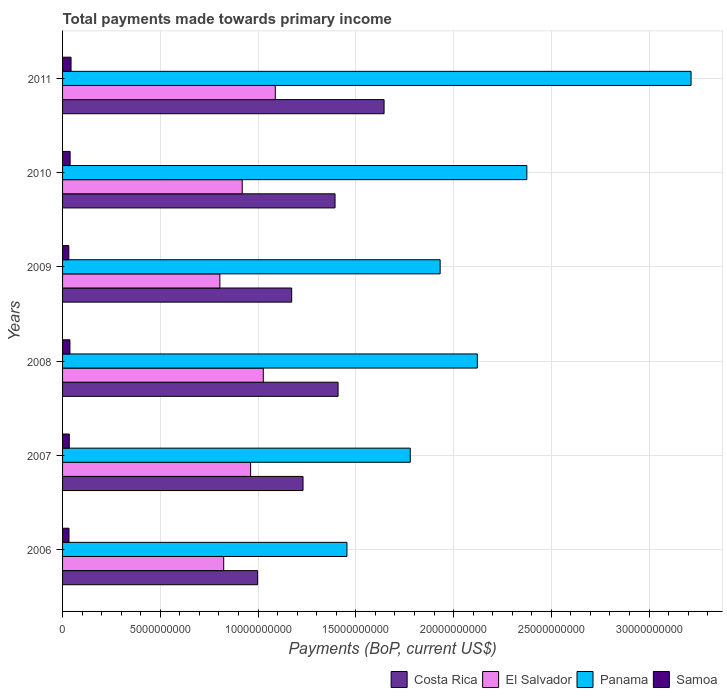How many different coloured bars are there?
Your response must be concise. 4. Are the number of bars per tick equal to the number of legend labels?
Give a very brief answer. Yes. Are the number of bars on each tick of the Y-axis equal?
Offer a terse response. Yes. How many bars are there on the 1st tick from the top?
Give a very brief answer. 4. In how many cases, is the number of bars for a given year not equal to the number of legend labels?
Offer a very short reply. 0. What is the total payments made towards primary income in Samoa in 2009?
Your answer should be very brief. 3.20e+08. Across all years, what is the maximum total payments made towards primary income in El Salvador?
Provide a short and direct response. 1.09e+1. Across all years, what is the minimum total payments made towards primary income in Samoa?
Your response must be concise. 3.20e+08. In which year was the total payments made towards primary income in Costa Rica minimum?
Your answer should be very brief. 2006. What is the total total payments made towards primary income in Samoa in the graph?
Your answer should be very brief. 2.19e+09. What is the difference between the total payments made towards primary income in Costa Rica in 2006 and that in 2007?
Offer a terse response. -2.32e+09. What is the difference between the total payments made towards primary income in Panama in 2010 and the total payments made towards primary income in El Salvador in 2009?
Provide a succinct answer. 1.57e+1. What is the average total payments made towards primary income in Costa Rica per year?
Your answer should be very brief. 1.31e+1. In the year 2011, what is the difference between the total payments made towards primary income in El Salvador and total payments made towards primary income in Samoa?
Provide a short and direct response. 1.04e+1. What is the ratio of the total payments made towards primary income in El Salvador in 2007 to that in 2011?
Your response must be concise. 0.88. Is the total payments made towards primary income in El Salvador in 2006 less than that in 2010?
Keep it short and to the point. Yes. Is the difference between the total payments made towards primary income in El Salvador in 2006 and 2011 greater than the difference between the total payments made towards primary income in Samoa in 2006 and 2011?
Make the answer very short. No. What is the difference between the highest and the second highest total payments made towards primary income in Samoa?
Offer a terse response. 4.78e+07. What is the difference between the highest and the lowest total payments made towards primary income in Panama?
Your response must be concise. 1.76e+1. In how many years, is the total payments made towards primary income in El Salvador greater than the average total payments made towards primary income in El Salvador taken over all years?
Offer a very short reply. 3. Is the sum of the total payments made towards primary income in Samoa in 2006 and 2011 greater than the maximum total payments made towards primary income in Panama across all years?
Your answer should be very brief. No. What does the 2nd bar from the top in 2011 represents?
Your response must be concise. Panama. What does the 4th bar from the bottom in 2009 represents?
Keep it short and to the point. Samoa. Is it the case that in every year, the sum of the total payments made towards primary income in Panama and total payments made towards primary income in Costa Rica is greater than the total payments made towards primary income in El Salvador?
Offer a terse response. Yes. How many years are there in the graph?
Make the answer very short. 6. Are the values on the major ticks of X-axis written in scientific E-notation?
Provide a succinct answer. No. Does the graph contain any zero values?
Ensure brevity in your answer.  No. Where does the legend appear in the graph?
Your response must be concise. Bottom right. How are the legend labels stacked?
Provide a succinct answer. Horizontal. What is the title of the graph?
Offer a terse response. Total payments made towards primary income. What is the label or title of the X-axis?
Offer a terse response. Payments (BoP, current US$). What is the Payments (BoP, current US$) in Costa Rica in 2006?
Ensure brevity in your answer.  9.98e+09. What is the Payments (BoP, current US$) in El Salvador in 2006?
Offer a very short reply. 8.24e+09. What is the Payments (BoP, current US$) of Panama in 2006?
Your answer should be compact. 1.45e+1. What is the Payments (BoP, current US$) in Samoa in 2006?
Offer a very short reply. 3.29e+08. What is the Payments (BoP, current US$) in Costa Rica in 2007?
Offer a very short reply. 1.23e+1. What is the Payments (BoP, current US$) of El Salvador in 2007?
Provide a short and direct response. 9.62e+09. What is the Payments (BoP, current US$) in Panama in 2007?
Provide a short and direct response. 1.78e+1. What is the Payments (BoP, current US$) of Samoa in 2007?
Your response must be concise. 3.44e+08. What is the Payments (BoP, current US$) of Costa Rica in 2008?
Provide a short and direct response. 1.41e+1. What is the Payments (BoP, current US$) of El Salvador in 2008?
Ensure brevity in your answer.  1.03e+1. What is the Payments (BoP, current US$) in Panama in 2008?
Provide a succinct answer. 2.12e+1. What is the Payments (BoP, current US$) in Samoa in 2008?
Your response must be concise. 3.77e+08. What is the Payments (BoP, current US$) in Costa Rica in 2009?
Provide a succinct answer. 1.17e+1. What is the Payments (BoP, current US$) in El Salvador in 2009?
Offer a very short reply. 8.05e+09. What is the Payments (BoP, current US$) of Panama in 2009?
Make the answer very short. 1.93e+1. What is the Payments (BoP, current US$) of Samoa in 2009?
Your answer should be compact. 3.20e+08. What is the Payments (BoP, current US$) of Costa Rica in 2010?
Your answer should be compact. 1.39e+1. What is the Payments (BoP, current US$) in El Salvador in 2010?
Make the answer very short. 9.19e+09. What is the Payments (BoP, current US$) of Panama in 2010?
Your answer should be compact. 2.37e+1. What is the Payments (BoP, current US$) of Samoa in 2010?
Keep it short and to the point. 3.86e+08. What is the Payments (BoP, current US$) of Costa Rica in 2011?
Your answer should be compact. 1.64e+1. What is the Payments (BoP, current US$) of El Salvador in 2011?
Give a very brief answer. 1.09e+1. What is the Payments (BoP, current US$) in Panama in 2011?
Your answer should be compact. 3.21e+1. What is the Payments (BoP, current US$) of Samoa in 2011?
Make the answer very short. 4.34e+08. Across all years, what is the maximum Payments (BoP, current US$) in Costa Rica?
Ensure brevity in your answer.  1.64e+1. Across all years, what is the maximum Payments (BoP, current US$) of El Salvador?
Ensure brevity in your answer.  1.09e+1. Across all years, what is the maximum Payments (BoP, current US$) of Panama?
Offer a very short reply. 3.21e+1. Across all years, what is the maximum Payments (BoP, current US$) in Samoa?
Provide a succinct answer. 4.34e+08. Across all years, what is the minimum Payments (BoP, current US$) in Costa Rica?
Provide a short and direct response. 9.98e+09. Across all years, what is the minimum Payments (BoP, current US$) in El Salvador?
Your response must be concise. 8.05e+09. Across all years, what is the minimum Payments (BoP, current US$) of Panama?
Offer a very short reply. 1.45e+1. Across all years, what is the minimum Payments (BoP, current US$) of Samoa?
Your answer should be compact. 3.20e+08. What is the total Payments (BoP, current US$) of Costa Rica in the graph?
Your answer should be very brief. 7.85e+1. What is the total Payments (BoP, current US$) in El Salvador in the graph?
Your answer should be very brief. 5.62e+1. What is the total Payments (BoP, current US$) in Panama in the graph?
Provide a succinct answer. 1.29e+11. What is the total Payments (BoP, current US$) of Samoa in the graph?
Offer a terse response. 2.19e+09. What is the difference between the Payments (BoP, current US$) in Costa Rica in 2006 and that in 2007?
Offer a terse response. -2.32e+09. What is the difference between the Payments (BoP, current US$) of El Salvador in 2006 and that in 2007?
Give a very brief answer. -1.38e+09. What is the difference between the Payments (BoP, current US$) in Panama in 2006 and that in 2007?
Your response must be concise. -3.24e+09. What is the difference between the Payments (BoP, current US$) in Samoa in 2006 and that in 2007?
Give a very brief answer. -1.56e+07. What is the difference between the Payments (BoP, current US$) in Costa Rica in 2006 and that in 2008?
Give a very brief answer. -4.12e+09. What is the difference between the Payments (BoP, current US$) in El Salvador in 2006 and that in 2008?
Offer a very short reply. -2.03e+09. What is the difference between the Payments (BoP, current US$) in Panama in 2006 and that in 2008?
Your response must be concise. -6.67e+09. What is the difference between the Payments (BoP, current US$) of Samoa in 2006 and that in 2008?
Your answer should be very brief. -4.81e+07. What is the difference between the Payments (BoP, current US$) in Costa Rica in 2006 and that in 2009?
Your answer should be very brief. -1.74e+09. What is the difference between the Payments (BoP, current US$) of El Salvador in 2006 and that in 2009?
Offer a very short reply. 1.96e+08. What is the difference between the Payments (BoP, current US$) of Panama in 2006 and that in 2009?
Your answer should be compact. -4.77e+09. What is the difference between the Payments (BoP, current US$) of Samoa in 2006 and that in 2009?
Give a very brief answer. 8.97e+06. What is the difference between the Payments (BoP, current US$) in Costa Rica in 2006 and that in 2010?
Offer a terse response. -3.96e+09. What is the difference between the Payments (BoP, current US$) of El Salvador in 2006 and that in 2010?
Your answer should be very brief. -9.47e+08. What is the difference between the Payments (BoP, current US$) of Panama in 2006 and that in 2010?
Your answer should be very brief. -9.20e+09. What is the difference between the Payments (BoP, current US$) of Samoa in 2006 and that in 2010?
Your response must be concise. -5.76e+07. What is the difference between the Payments (BoP, current US$) of Costa Rica in 2006 and that in 2011?
Keep it short and to the point. -6.47e+09. What is the difference between the Payments (BoP, current US$) in El Salvador in 2006 and that in 2011?
Your response must be concise. -2.64e+09. What is the difference between the Payments (BoP, current US$) in Panama in 2006 and that in 2011?
Keep it short and to the point. -1.76e+1. What is the difference between the Payments (BoP, current US$) in Samoa in 2006 and that in 2011?
Your response must be concise. -1.05e+08. What is the difference between the Payments (BoP, current US$) of Costa Rica in 2007 and that in 2008?
Give a very brief answer. -1.79e+09. What is the difference between the Payments (BoP, current US$) in El Salvador in 2007 and that in 2008?
Offer a very short reply. -6.48e+08. What is the difference between the Payments (BoP, current US$) in Panama in 2007 and that in 2008?
Offer a very short reply. -3.43e+09. What is the difference between the Payments (BoP, current US$) of Samoa in 2007 and that in 2008?
Offer a terse response. -3.25e+07. What is the difference between the Payments (BoP, current US$) of Costa Rica in 2007 and that in 2009?
Give a very brief answer. 5.80e+08. What is the difference between the Payments (BoP, current US$) in El Salvador in 2007 and that in 2009?
Provide a short and direct response. 1.57e+09. What is the difference between the Payments (BoP, current US$) of Panama in 2007 and that in 2009?
Your answer should be very brief. -1.53e+09. What is the difference between the Payments (BoP, current US$) of Samoa in 2007 and that in 2009?
Your answer should be very brief. 2.46e+07. What is the difference between the Payments (BoP, current US$) in Costa Rica in 2007 and that in 2010?
Give a very brief answer. -1.64e+09. What is the difference between the Payments (BoP, current US$) of El Salvador in 2007 and that in 2010?
Make the answer very short. 4.30e+08. What is the difference between the Payments (BoP, current US$) of Panama in 2007 and that in 2010?
Offer a terse response. -5.96e+09. What is the difference between the Payments (BoP, current US$) in Samoa in 2007 and that in 2010?
Your answer should be very brief. -4.20e+07. What is the difference between the Payments (BoP, current US$) in Costa Rica in 2007 and that in 2011?
Keep it short and to the point. -4.15e+09. What is the difference between the Payments (BoP, current US$) of El Salvador in 2007 and that in 2011?
Provide a short and direct response. -1.26e+09. What is the difference between the Payments (BoP, current US$) in Panama in 2007 and that in 2011?
Provide a succinct answer. -1.44e+1. What is the difference between the Payments (BoP, current US$) of Samoa in 2007 and that in 2011?
Offer a terse response. -8.98e+07. What is the difference between the Payments (BoP, current US$) of Costa Rica in 2008 and that in 2009?
Offer a terse response. 2.37e+09. What is the difference between the Payments (BoP, current US$) of El Salvador in 2008 and that in 2009?
Your answer should be compact. 2.22e+09. What is the difference between the Payments (BoP, current US$) of Panama in 2008 and that in 2009?
Your answer should be compact. 1.90e+09. What is the difference between the Payments (BoP, current US$) of Samoa in 2008 and that in 2009?
Give a very brief answer. 5.70e+07. What is the difference between the Payments (BoP, current US$) of Costa Rica in 2008 and that in 2010?
Make the answer very short. 1.55e+08. What is the difference between the Payments (BoP, current US$) of El Salvador in 2008 and that in 2010?
Your answer should be very brief. 1.08e+09. What is the difference between the Payments (BoP, current US$) in Panama in 2008 and that in 2010?
Your answer should be compact. -2.53e+09. What is the difference between the Payments (BoP, current US$) of Samoa in 2008 and that in 2010?
Your response must be concise. -9.55e+06. What is the difference between the Payments (BoP, current US$) in Costa Rica in 2008 and that in 2011?
Give a very brief answer. -2.35e+09. What is the difference between the Payments (BoP, current US$) in El Salvador in 2008 and that in 2011?
Make the answer very short. -6.14e+08. What is the difference between the Payments (BoP, current US$) of Panama in 2008 and that in 2011?
Your answer should be compact. -1.09e+1. What is the difference between the Payments (BoP, current US$) in Samoa in 2008 and that in 2011?
Ensure brevity in your answer.  -5.74e+07. What is the difference between the Payments (BoP, current US$) in Costa Rica in 2009 and that in 2010?
Provide a succinct answer. -2.22e+09. What is the difference between the Payments (BoP, current US$) of El Salvador in 2009 and that in 2010?
Your answer should be very brief. -1.14e+09. What is the difference between the Payments (BoP, current US$) in Panama in 2009 and that in 2010?
Provide a succinct answer. -4.43e+09. What is the difference between the Payments (BoP, current US$) in Samoa in 2009 and that in 2010?
Provide a short and direct response. -6.66e+07. What is the difference between the Payments (BoP, current US$) in Costa Rica in 2009 and that in 2011?
Your response must be concise. -4.73e+09. What is the difference between the Payments (BoP, current US$) in El Salvador in 2009 and that in 2011?
Offer a terse response. -2.83e+09. What is the difference between the Payments (BoP, current US$) in Panama in 2009 and that in 2011?
Your response must be concise. -1.28e+1. What is the difference between the Payments (BoP, current US$) in Samoa in 2009 and that in 2011?
Make the answer very short. -1.14e+08. What is the difference between the Payments (BoP, current US$) of Costa Rica in 2010 and that in 2011?
Provide a short and direct response. -2.51e+09. What is the difference between the Payments (BoP, current US$) in El Salvador in 2010 and that in 2011?
Give a very brief answer. -1.69e+09. What is the difference between the Payments (BoP, current US$) in Panama in 2010 and that in 2011?
Give a very brief answer. -8.40e+09. What is the difference between the Payments (BoP, current US$) in Samoa in 2010 and that in 2011?
Offer a terse response. -4.78e+07. What is the difference between the Payments (BoP, current US$) of Costa Rica in 2006 and the Payments (BoP, current US$) of El Salvador in 2007?
Make the answer very short. 3.57e+08. What is the difference between the Payments (BoP, current US$) of Costa Rica in 2006 and the Payments (BoP, current US$) of Panama in 2007?
Make the answer very short. -7.81e+09. What is the difference between the Payments (BoP, current US$) in Costa Rica in 2006 and the Payments (BoP, current US$) in Samoa in 2007?
Ensure brevity in your answer.  9.63e+09. What is the difference between the Payments (BoP, current US$) of El Salvador in 2006 and the Payments (BoP, current US$) of Panama in 2007?
Provide a short and direct response. -9.54e+09. What is the difference between the Payments (BoP, current US$) in El Salvador in 2006 and the Payments (BoP, current US$) in Samoa in 2007?
Offer a terse response. 7.90e+09. What is the difference between the Payments (BoP, current US$) in Panama in 2006 and the Payments (BoP, current US$) in Samoa in 2007?
Your response must be concise. 1.42e+1. What is the difference between the Payments (BoP, current US$) in Costa Rica in 2006 and the Payments (BoP, current US$) in El Salvador in 2008?
Your response must be concise. -2.91e+08. What is the difference between the Payments (BoP, current US$) in Costa Rica in 2006 and the Payments (BoP, current US$) in Panama in 2008?
Offer a terse response. -1.12e+1. What is the difference between the Payments (BoP, current US$) of Costa Rica in 2006 and the Payments (BoP, current US$) of Samoa in 2008?
Provide a short and direct response. 9.60e+09. What is the difference between the Payments (BoP, current US$) in El Salvador in 2006 and the Payments (BoP, current US$) in Panama in 2008?
Ensure brevity in your answer.  -1.30e+1. What is the difference between the Payments (BoP, current US$) in El Salvador in 2006 and the Payments (BoP, current US$) in Samoa in 2008?
Keep it short and to the point. 7.87e+09. What is the difference between the Payments (BoP, current US$) in Panama in 2006 and the Payments (BoP, current US$) in Samoa in 2008?
Make the answer very short. 1.42e+1. What is the difference between the Payments (BoP, current US$) of Costa Rica in 2006 and the Payments (BoP, current US$) of El Salvador in 2009?
Keep it short and to the point. 1.93e+09. What is the difference between the Payments (BoP, current US$) in Costa Rica in 2006 and the Payments (BoP, current US$) in Panama in 2009?
Make the answer very short. -9.34e+09. What is the difference between the Payments (BoP, current US$) in Costa Rica in 2006 and the Payments (BoP, current US$) in Samoa in 2009?
Your answer should be compact. 9.66e+09. What is the difference between the Payments (BoP, current US$) of El Salvador in 2006 and the Payments (BoP, current US$) of Panama in 2009?
Give a very brief answer. -1.11e+1. What is the difference between the Payments (BoP, current US$) of El Salvador in 2006 and the Payments (BoP, current US$) of Samoa in 2009?
Keep it short and to the point. 7.92e+09. What is the difference between the Payments (BoP, current US$) of Panama in 2006 and the Payments (BoP, current US$) of Samoa in 2009?
Ensure brevity in your answer.  1.42e+1. What is the difference between the Payments (BoP, current US$) of Costa Rica in 2006 and the Payments (BoP, current US$) of El Salvador in 2010?
Offer a terse response. 7.87e+08. What is the difference between the Payments (BoP, current US$) in Costa Rica in 2006 and the Payments (BoP, current US$) in Panama in 2010?
Provide a short and direct response. -1.38e+1. What is the difference between the Payments (BoP, current US$) in Costa Rica in 2006 and the Payments (BoP, current US$) in Samoa in 2010?
Offer a terse response. 9.59e+09. What is the difference between the Payments (BoP, current US$) in El Salvador in 2006 and the Payments (BoP, current US$) in Panama in 2010?
Provide a short and direct response. -1.55e+1. What is the difference between the Payments (BoP, current US$) of El Salvador in 2006 and the Payments (BoP, current US$) of Samoa in 2010?
Ensure brevity in your answer.  7.86e+09. What is the difference between the Payments (BoP, current US$) of Panama in 2006 and the Payments (BoP, current US$) of Samoa in 2010?
Ensure brevity in your answer.  1.42e+1. What is the difference between the Payments (BoP, current US$) in Costa Rica in 2006 and the Payments (BoP, current US$) in El Salvador in 2011?
Make the answer very short. -9.05e+08. What is the difference between the Payments (BoP, current US$) of Costa Rica in 2006 and the Payments (BoP, current US$) of Panama in 2011?
Your answer should be compact. -2.22e+1. What is the difference between the Payments (BoP, current US$) in Costa Rica in 2006 and the Payments (BoP, current US$) in Samoa in 2011?
Provide a short and direct response. 9.54e+09. What is the difference between the Payments (BoP, current US$) in El Salvador in 2006 and the Payments (BoP, current US$) in Panama in 2011?
Offer a very short reply. -2.39e+1. What is the difference between the Payments (BoP, current US$) in El Salvador in 2006 and the Payments (BoP, current US$) in Samoa in 2011?
Make the answer very short. 7.81e+09. What is the difference between the Payments (BoP, current US$) in Panama in 2006 and the Payments (BoP, current US$) in Samoa in 2011?
Your response must be concise. 1.41e+1. What is the difference between the Payments (BoP, current US$) in Costa Rica in 2007 and the Payments (BoP, current US$) in El Salvador in 2008?
Your response must be concise. 2.03e+09. What is the difference between the Payments (BoP, current US$) in Costa Rica in 2007 and the Payments (BoP, current US$) in Panama in 2008?
Make the answer very short. -8.92e+09. What is the difference between the Payments (BoP, current US$) of Costa Rica in 2007 and the Payments (BoP, current US$) of Samoa in 2008?
Your response must be concise. 1.19e+1. What is the difference between the Payments (BoP, current US$) of El Salvador in 2007 and the Payments (BoP, current US$) of Panama in 2008?
Provide a short and direct response. -1.16e+1. What is the difference between the Payments (BoP, current US$) of El Salvador in 2007 and the Payments (BoP, current US$) of Samoa in 2008?
Provide a succinct answer. 9.24e+09. What is the difference between the Payments (BoP, current US$) of Panama in 2007 and the Payments (BoP, current US$) of Samoa in 2008?
Offer a terse response. 1.74e+1. What is the difference between the Payments (BoP, current US$) in Costa Rica in 2007 and the Payments (BoP, current US$) in El Salvador in 2009?
Keep it short and to the point. 4.25e+09. What is the difference between the Payments (BoP, current US$) in Costa Rica in 2007 and the Payments (BoP, current US$) in Panama in 2009?
Offer a very short reply. -7.01e+09. What is the difference between the Payments (BoP, current US$) in Costa Rica in 2007 and the Payments (BoP, current US$) in Samoa in 2009?
Offer a very short reply. 1.20e+1. What is the difference between the Payments (BoP, current US$) in El Salvador in 2007 and the Payments (BoP, current US$) in Panama in 2009?
Provide a succinct answer. -9.69e+09. What is the difference between the Payments (BoP, current US$) in El Salvador in 2007 and the Payments (BoP, current US$) in Samoa in 2009?
Offer a terse response. 9.30e+09. What is the difference between the Payments (BoP, current US$) of Panama in 2007 and the Payments (BoP, current US$) of Samoa in 2009?
Offer a very short reply. 1.75e+1. What is the difference between the Payments (BoP, current US$) of Costa Rica in 2007 and the Payments (BoP, current US$) of El Salvador in 2010?
Your response must be concise. 3.11e+09. What is the difference between the Payments (BoP, current US$) of Costa Rica in 2007 and the Payments (BoP, current US$) of Panama in 2010?
Provide a succinct answer. -1.14e+1. What is the difference between the Payments (BoP, current US$) in Costa Rica in 2007 and the Payments (BoP, current US$) in Samoa in 2010?
Offer a very short reply. 1.19e+1. What is the difference between the Payments (BoP, current US$) of El Salvador in 2007 and the Payments (BoP, current US$) of Panama in 2010?
Your response must be concise. -1.41e+1. What is the difference between the Payments (BoP, current US$) of El Salvador in 2007 and the Payments (BoP, current US$) of Samoa in 2010?
Your answer should be very brief. 9.23e+09. What is the difference between the Payments (BoP, current US$) in Panama in 2007 and the Payments (BoP, current US$) in Samoa in 2010?
Your response must be concise. 1.74e+1. What is the difference between the Payments (BoP, current US$) in Costa Rica in 2007 and the Payments (BoP, current US$) in El Salvador in 2011?
Make the answer very short. 1.42e+09. What is the difference between the Payments (BoP, current US$) in Costa Rica in 2007 and the Payments (BoP, current US$) in Panama in 2011?
Provide a succinct answer. -1.98e+1. What is the difference between the Payments (BoP, current US$) in Costa Rica in 2007 and the Payments (BoP, current US$) in Samoa in 2011?
Your answer should be very brief. 1.19e+1. What is the difference between the Payments (BoP, current US$) of El Salvador in 2007 and the Payments (BoP, current US$) of Panama in 2011?
Your answer should be very brief. -2.25e+1. What is the difference between the Payments (BoP, current US$) in El Salvador in 2007 and the Payments (BoP, current US$) in Samoa in 2011?
Give a very brief answer. 9.19e+09. What is the difference between the Payments (BoP, current US$) of Panama in 2007 and the Payments (BoP, current US$) of Samoa in 2011?
Your answer should be very brief. 1.74e+1. What is the difference between the Payments (BoP, current US$) in Costa Rica in 2008 and the Payments (BoP, current US$) in El Salvador in 2009?
Offer a terse response. 6.05e+09. What is the difference between the Payments (BoP, current US$) of Costa Rica in 2008 and the Payments (BoP, current US$) of Panama in 2009?
Your answer should be compact. -5.22e+09. What is the difference between the Payments (BoP, current US$) of Costa Rica in 2008 and the Payments (BoP, current US$) of Samoa in 2009?
Provide a succinct answer. 1.38e+1. What is the difference between the Payments (BoP, current US$) of El Salvador in 2008 and the Payments (BoP, current US$) of Panama in 2009?
Provide a short and direct response. -9.05e+09. What is the difference between the Payments (BoP, current US$) of El Salvador in 2008 and the Payments (BoP, current US$) of Samoa in 2009?
Provide a short and direct response. 9.95e+09. What is the difference between the Payments (BoP, current US$) of Panama in 2008 and the Payments (BoP, current US$) of Samoa in 2009?
Offer a very short reply. 2.09e+1. What is the difference between the Payments (BoP, current US$) in Costa Rica in 2008 and the Payments (BoP, current US$) in El Salvador in 2010?
Make the answer very short. 4.90e+09. What is the difference between the Payments (BoP, current US$) of Costa Rica in 2008 and the Payments (BoP, current US$) of Panama in 2010?
Give a very brief answer. -9.66e+09. What is the difference between the Payments (BoP, current US$) of Costa Rica in 2008 and the Payments (BoP, current US$) of Samoa in 2010?
Make the answer very short. 1.37e+1. What is the difference between the Payments (BoP, current US$) in El Salvador in 2008 and the Payments (BoP, current US$) in Panama in 2010?
Your answer should be compact. -1.35e+1. What is the difference between the Payments (BoP, current US$) of El Salvador in 2008 and the Payments (BoP, current US$) of Samoa in 2010?
Offer a very short reply. 9.88e+09. What is the difference between the Payments (BoP, current US$) of Panama in 2008 and the Payments (BoP, current US$) of Samoa in 2010?
Provide a succinct answer. 2.08e+1. What is the difference between the Payments (BoP, current US$) in Costa Rica in 2008 and the Payments (BoP, current US$) in El Salvador in 2011?
Make the answer very short. 3.21e+09. What is the difference between the Payments (BoP, current US$) of Costa Rica in 2008 and the Payments (BoP, current US$) of Panama in 2011?
Your answer should be compact. -1.81e+1. What is the difference between the Payments (BoP, current US$) of Costa Rica in 2008 and the Payments (BoP, current US$) of Samoa in 2011?
Offer a terse response. 1.37e+1. What is the difference between the Payments (BoP, current US$) of El Salvador in 2008 and the Payments (BoP, current US$) of Panama in 2011?
Provide a short and direct response. -2.19e+1. What is the difference between the Payments (BoP, current US$) in El Salvador in 2008 and the Payments (BoP, current US$) in Samoa in 2011?
Your response must be concise. 9.83e+09. What is the difference between the Payments (BoP, current US$) in Panama in 2008 and the Payments (BoP, current US$) in Samoa in 2011?
Provide a short and direct response. 2.08e+1. What is the difference between the Payments (BoP, current US$) of Costa Rica in 2009 and the Payments (BoP, current US$) of El Salvador in 2010?
Offer a very short reply. 2.53e+09. What is the difference between the Payments (BoP, current US$) in Costa Rica in 2009 and the Payments (BoP, current US$) in Panama in 2010?
Give a very brief answer. -1.20e+1. What is the difference between the Payments (BoP, current US$) in Costa Rica in 2009 and the Payments (BoP, current US$) in Samoa in 2010?
Keep it short and to the point. 1.13e+1. What is the difference between the Payments (BoP, current US$) in El Salvador in 2009 and the Payments (BoP, current US$) in Panama in 2010?
Provide a short and direct response. -1.57e+1. What is the difference between the Payments (BoP, current US$) in El Salvador in 2009 and the Payments (BoP, current US$) in Samoa in 2010?
Your response must be concise. 7.66e+09. What is the difference between the Payments (BoP, current US$) in Panama in 2009 and the Payments (BoP, current US$) in Samoa in 2010?
Offer a terse response. 1.89e+1. What is the difference between the Payments (BoP, current US$) of Costa Rica in 2009 and the Payments (BoP, current US$) of El Salvador in 2011?
Ensure brevity in your answer.  8.38e+08. What is the difference between the Payments (BoP, current US$) in Costa Rica in 2009 and the Payments (BoP, current US$) in Panama in 2011?
Offer a very short reply. -2.04e+1. What is the difference between the Payments (BoP, current US$) in Costa Rica in 2009 and the Payments (BoP, current US$) in Samoa in 2011?
Your response must be concise. 1.13e+1. What is the difference between the Payments (BoP, current US$) in El Salvador in 2009 and the Payments (BoP, current US$) in Panama in 2011?
Your answer should be very brief. -2.41e+1. What is the difference between the Payments (BoP, current US$) of El Salvador in 2009 and the Payments (BoP, current US$) of Samoa in 2011?
Provide a short and direct response. 7.61e+09. What is the difference between the Payments (BoP, current US$) in Panama in 2009 and the Payments (BoP, current US$) in Samoa in 2011?
Your answer should be very brief. 1.89e+1. What is the difference between the Payments (BoP, current US$) in Costa Rica in 2010 and the Payments (BoP, current US$) in El Salvador in 2011?
Offer a terse response. 3.06e+09. What is the difference between the Payments (BoP, current US$) in Costa Rica in 2010 and the Payments (BoP, current US$) in Panama in 2011?
Your answer should be very brief. -1.82e+1. What is the difference between the Payments (BoP, current US$) of Costa Rica in 2010 and the Payments (BoP, current US$) of Samoa in 2011?
Provide a succinct answer. 1.35e+1. What is the difference between the Payments (BoP, current US$) of El Salvador in 2010 and the Payments (BoP, current US$) of Panama in 2011?
Provide a succinct answer. -2.30e+1. What is the difference between the Payments (BoP, current US$) in El Salvador in 2010 and the Payments (BoP, current US$) in Samoa in 2011?
Provide a succinct answer. 8.76e+09. What is the difference between the Payments (BoP, current US$) in Panama in 2010 and the Payments (BoP, current US$) in Samoa in 2011?
Provide a short and direct response. 2.33e+1. What is the average Payments (BoP, current US$) in Costa Rica per year?
Provide a short and direct response. 1.31e+1. What is the average Payments (BoP, current US$) of El Salvador per year?
Provide a succinct answer. 9.37e+09. What is the average Payments (BoP, current US$) in Panama per year?
Give a very brief answer. 2.15e+1. What is the average Payments (BoP, current US$) in Samoa per year?
Your answer should be very brief. 3.65e+08. In the year 2006, what is the difference between the Payments (BoP, current US$) in Costa Rica and Payments (BoP, current US$) in El Salvador?
Provide a succinct answer. 1.73e+09. In the year 2006, what is the difference between the Payments (BoP, current US$) of Costa Rica and Payments (BoP, current US$) of Panama?
Provide a succinct answer. -4.57e+09. In the year 2006, what is the difference between the Payments (BoP, current US$) in Costa Rica and Payments (BoP, current US$) in Samoa?
Provide a short and direct response. 9.65e+09. In the year 2006, what is the difference between the Payments (BoP, current US$) in El Salvador and Payments (BoP, current US$) in Panama?
Keep it short and to the point. -6.30e+09. In the year 2006, what is the difference between the Payments (BoP, current US$) in El Salvador and Payments (BoP, current US$) in Samoa?
Ensure brevity in your answer.  7.91e+09. In the year 2006, what is the difference between the Payments (BoP, current US$) of Panama and Payments (BoP, current US$) of Samoa?
Offer a terse response. 1.42e+1. In the year 2007, what is the difference between the Payments (BoP, current US$) of Costa Rica and Payments (BoP, current US$) of El Salvador?
Ensure brevity in your answer.  2.68e+09. In the year 2007, what is the difference between the Payments (BoP, current US$) in Costa Rica and Payments (BoP, current US$) in Panama?
Your response must be concise. -5.48e+09. In the year 2007, what is the difference between the Payments (BoP, current US$) of Costa Rica and Payments (BoP, current US$) of Samoa?
Keep it short and to the point. 1.20e+1. In the year 2007, what is the difference between the Payments (BoP, current US$) in El Salvador and Payments (BoP, current US$) in Panama?
Your answer should be compact. -8.16e+09. In the year 2007, what is the difference between the Payments (BoP, current US$) in El Salvador and Payments (BoP, current US$) in Samoa?
Give a very brief answer. 9.28e+09. In the year 2007, what is the difference between the Payments (BoP, current US$) in Panama and Payments (BoP, current US$) in Samoa?
Offer a terse response. 1.74e+1. In the year 2008, what is the difference between the Payments (BoP, current US$) in Costa Rica and Payments (BoP, current US$) in El Salvador?
Provide a succinct answer. 3.82e+09. In the year 2008, what is the difference between the Payments (BoP, current US$) in Costa Rica and Payments (BoP, current US$) in Panama?
Provide a short and direct response. -7.12e+09. In the year 2008, what is the difference between the Payments (BoP, current US$) in Costa Rica and Payments (BoP, current US$) in Samoa?
Give a very brief answer. 1.37e+1. In the year 2008, what is the difference between the Payments (BoP, current US$) in El Salvador and Payments (BoP, current US$) in Panama?
Your answer should be compact. -1.09e+1. In the year 2008, what is the difference between the Payments (BoP, current US$) in El Salvador and Payments (BoP, current US$) in Samoa?
Offer a very short reply. 9.89e+09. In the year 2008, what is the difference between the Payments (BoP, current US$) of Panama and Payments (BoP, current US$) of Samoa?
Provide a short and direct response. 2.08e+1. In the year 2009, what is the difference between the Payments (BoP, current US$) in Costa Rica and Payments (BoP, current US$) in El Salvador?
Keep it short and to the point. 3.67e+09. In the year 2009, what is the difference between the Payments (BoP, current US$) in Costa Rica and Payments (BoP, current US$) in Panama?
Ensure brevity in your answer.  -7.59e+09. In the year 2009, what is the difference between the Payments (BoP, current US$) in Costa Rica and Payments (BoP, current US$) in Samoa?
Offer a terse response. 1.14e+1. In the year 2009, what is the difference between the Payments (BoP, current US$) in El Salvador and Payments (BoP, current US$) in Panama?
Ensure brevity in your answer.  -1.13e+1. In the year 2009, what is the difference between the Payments (BoP, current US$) in El Salvador and Payments (BoP, current US$) in Samoa?
Ensure brevity in your answer.  7.73e+09. In the year 2009, what is the difference between the Payments (BoP, current US$) of Panama and Payments (BoP, current US$) of Samoa?
Make the answer very short. 1.90e+1. In the year 2010, what is the difference between the Payments (BoP, current US$) of Costa Rica and Payments (BoP, current US$) of El Salvador?
Give a very brief answer. 4.75e+09. In the year 2010, what is the difference between the Payments (BoP, current US$) of Costa Rica and Payments (BoP, current US$) of Panama?
Offer a very short reply. -9.81e+09. In the year 2010, what is the difference between the Payments (BoP, current US$) of Costa Rica and Payments (BoP, current US$) of Samoa?
Your response must be concise. 1.36e+1. In the year 2010, what is the difference between the Payments (BoP, current US$) in El Salvador and Payments (BoP, current US$) in Panama?
Give a very brief answer. -1.46e+1. In the year 2010, what is the difference between the Payments (BoP, current US$) in El Salvador and Payments (BoP, current US$) in Samoa?
Give a very brief answer. 8.80e+09. In the year 2010, what is the difference between the Payments (BoP, current US$) of Panama and Payments (BoP, current US$) of Samoa?
Your response must be concise. 2.34e+1. In the year 2011, what is the difference between the Payments (BoP, current US$) of Costa Rica and Payments (BoP, current US$) of El Salvador?
Keep it short and to the point. 5.56e+09. In the year 2011, what is the difference between the Payments (BoP, current US$) in Costa Rica and Payments (BoP, current US$) in Panama?
Ensure brevity in your answer.  -1.57e+1. In the year 2011, what is the difference between the Payments (BoP, current US$) of Costa Rica and Payments (BoP, current US$) of Samoa?
Give a very brief answer. 1.60e+1. In the year 2011, what is the difference between the Payments (BoP, current US$) of El Salvador and Payments (BoP, current US$) of Panama?
Your response must be concise. -2.13e+1. In the year 2011, what is the difference between the Payments (BoP, current US$) of El Salvador and Payments (BoP, current US$) of Samoa?
Provide a succinct answer. 1.04e+1. In the year 2011, what is the difference between the Payments (BoP, current US$) of Panama and Payments (BoP, current US$) of Samoa?
Your response must be concise. 3.17e+1. What is the ratio of the Payments (BoP, current US$) in Costa Rica in 2006 to that in 2007?
Offer a terse response. 0.81. What is the ratio of the Payments (BoP, current US$) in El Salvador in 2006 to that in 2007?
Offer a very short reply. 0.86. What is the ratio of the Payments (BoP, current US$) in Panama in 2006 to that in 2007?
Your answer should be very brief. 0.82. What is the ratio of the Payments (BoP, current US$) of Samoa in 2006 to that in 2007?
Your answer should be compact. 0.95. What is the ratio of the Payments (BoP, current US$) in Costa Rica in 2006 to that in 2008?
Offer a very short reply. 0.71. What is the ratio of the Payments (BoP, current US$) of El Salvador in 2006 to that in 2008?
Provide a succinct answer. 0.8. What is the ratio of the Payments (BoP, current US$) in Panama in 2006 to that in 2008?
Your answer should be compact. 0.69. What is the ratio of the Payments (BoP, current US$) of Samoa in 2006 to that in 2008?
Your answer should be compact. 0.87. What is the ratio of the Payments (BoP, current US$) of Costa Rica in 2006 to that in 2009?
Your response must be concise. 0.85. What is the ratio of the Payments (BoP, current US$) in El Salvador in 2006 to that in 2009?
Ensure brevity in your answer.  1.02. What is the ratio of the Payments (BoP, current US$) in Panama in 2006 to that in 2009?
Keep it short and to the point. 0.75. What is the ratio of the Payments (BoP, current US$) of Samoa in 2006 to that in 2009?
Provide a succinct answer. 1.03. What is the ratio of the Payments (BoP, current US$) of Costa Rica in 2006 to that in 2010?
Give a very brief answer. 0.72. What is the ratio of the Payments (BoP, current US$) of El Salvador in 2006 to that in 2010?
Offer a terse response. 0.9. What is the ratio of the Payments (BoP, current US$) in Panama in 2006 to that in 2010?
Give a very brief answer. 0.61. What is the ratio of the Payments (BoP, current US$) in Samoa in 2006 to that in 2010?
Your response must be concise. 0.85. What is the ratio of the Payments (BoP, current US$) of Costa Rica in 2006 to that in 2011?
Give a very brief answer. 0.61. What is the ratio of the Payments (BoP, current US$) of El Salvador in 2006 to that in 2011?
Keep it short and to the point. 0.76. What is the ratio of the Payments (BoP, current US$) of Panama in 2006 to that in 2011?
Keep it short and to the point. 0.45. What is the ratio of the Payments (BoP, current US$) of Samoa in 2006 to that in 2011?
Provide a short and direct response. 0.76. What is the ratio of the Payments (BoP, current US$) in Costa Rica in 2007 to that in 2008?
Your answer should be compact. 0.87. What is the ratio of the Payments (BoP, current US$) in El Salvador in 2007 to that in 2008?
Your response must be concise. 0.94. What is the ratio of the Payments (BoP, current US$) of Panama in 2007 to that in 2008?
Give a very brief answer. 0.84. What is the ratio of the Payments (BoP, current US$) in Samoa in 2007 to that in 2008?
Offer a very short reply. 0.91. What is the ratio of the Payments (BoP, current US$) of Costa Rica in 2007 to that in 2009?
Your answer should be very brief. 1.05. What is the ratio of the Payments (BoP, current US$) of El Salvador in 2007 to that in 2009?
Your answer should be compact. 1.2. What is the ratio of the Payments (BoP, current US$) of Panama in 2007 to that in 2009?
Make the answer very short. 0.92. What is the ratio of the Payments (BoP, current US$) in Samoa in 2007 to that in 2009?
Offer a terse response. 1.08. What is the ratio of the Payments (BoP, current US$) in Costa Rica in 2007 to that in 2010?
Your response must be concise. 0.88. What is the ratio of the Payments (BoP, current US$) of El Salvador in 2007 to that in 2010?
Keep it short and to the point. 1.05. What is the ratio of the Payments (BoP, current US$) of Panama in 2007 to that in 2010?
Make the answer very short. 0.75. What is the ratio of the Payments (BoP, current US$) of Samoa in 2007 to that in 2010?
Your response must be concise. 0.89. What is the ratio of the Payments (BoP, current US$) of Costa Rica in 2007 to that in 2011?
Give a very brief answer. 0.75. What is the ratio of the Payments (BoP, current US$) in El Salvador in 2007 to that in 2011?
Provide a succinct answer. 0.88. What is the ratio of the Payments (BoP, current US$) of Panama in 2007 to that in 2011?
Ensure brevity in your answer.  0.55. What is the ratio of the Payments (BoP, current US$) of Samoa in 2007 to that in 2011?
Offer a terse response. 0.79. What is the ratio of the Payments (BoP, current US$) of Costa Rica in 2008 to that in 2009?
Offer a very short reply. 1.2. What is the ratio of the Payments (BoP, current US$) in El Salvador in 2008 to that in 2009?
Provide a succinct answer. 1.28. What is the ratio of the Payments (BoP, current US$) of Panama in 2008 to that in 2009?
Your answer should be compact. 1.1. What is the ratio of the Payments (BoP, current US$) in Samoa in 2008 to that in 2009?
Offer a terse response. 1.18. What is the ratio of the Payments (BoP, current US$) in Costa Rica in 2008 to that in 2010?
Your answer should be compact. 1.01. What is the ratio of the Payments (BoP, current US$) of El Salvador in 2008 to that in 2010?
Your answer should be compact. 1.12. What is the ratio of the Payments (BoP, current US$) of Panama in 2008 to that in 2010?
Your answer should be compact. 0.89. What is the ratio of the Payments (BoP, current US$) of Samoa in 2008 to that in 2010?
Ensure brevity in your answer.  0.98. What is the ratio of the Payments (BoP, current US$) in Costa Rica in 2008 to that in 2011?
Your response must be concise. 0.86. What is the ratio of the Payments (BoP, current US$) of El Salvador in 2008 to that in 2011?
Your response must be concise. 0.94. What is the ratio of the Payments (BoP, current US$) of Panama in 2008 to that in 2011?
Your answer should be very brief. 0.66. What is the ratio of the Payments (BoP, current US$) of Samoa in 2008 to that in 2011?
Offer a very short reply. 0.87. What is the ratio of the Payments (BoP, current US$) of Costa Rica in 2009 to that in 2010?
Your response must be concise. 0.84. What is the ratio of the Payments (BoP, current US$) of El Salvador in 2009 to that in 2010?
Your answer should be compact. 0.88. What is the ratio of the Payments (BoP, current US$) of Panama in 2009 to that in 2010?
Make the answer very short. 0.81. What is the ratio of the Payments (BoP, current US$) of Samoa in 2009 to that in 2010?
Give a very brief answer. 0.83. What is the ratio of the Payments (BoP, current US$) of Costa Rica in 2009 to that in 2011?
Offer a terse response. 0.71. What is the ratio of the Payments (BoP, current US$) in El Salvador in 2009 to that in 2011?
Keep it short and to the point. 0.74. What is the ratio of the Payments (BoP, current US$) of Panama in 2009 to that in 2011?
Your response must be concise. 0.6. What is the ratio of the Payments (BoP, current US$) in Samoa in 2009 to that in 2011?
Ensure brevity in your answer.  0.74. What is the ratio of the Payments (BoP, current US$) in Costa Rica in 2010 to that in 2011?
Offer a terse response. 0.85. What is the ratio of the Payments (BoP, current US$) of El Salvador in 2010 to that in 2011?
Offer a very short reply. 0.84. What is the ratio of the Payments (BoP, current US$) of Panama in 2010 to that in 2011?
Your answer should be very brief. 0.74. What is the ratio of the Payments (BoP, current US$) in Samoa in 2010 to that in 2011?
Provide a short and direct response. 0.89. What is the difference between the highest and the second highest Payments (BoP, current US$) in Costa Rica?
Offer a terse response. 2.35e+09. What is the difference between the highest and the second highest Payments (BoP, current US$) of El Salvador?
Your response must be concise. 6.14e+08. What is the difference between the highest and the second highest Payments (BoP, current US$) of Panama?
Keep it short and to the point. 8.40e+09. What is the difference between the highest and the second highest Payments (BoP, current US$) in Samoa?
Your answer should be very brief. 4.78e+07. What is the difference between the highest and the lowest Payments (BoP, current US$) of Costa Rica?
Offer a terse response. 6.47e+09. What is the difference between the highest and the lowest Payments (BoP, current US$) of El Salvador?
Offer a terse response. 2.83e+09. What is the difference between the highest and the lowest Payments (BoP, current US$) in Panama?
Your answer should be compact. 1.76e+1. What is the difference between the highest and the lowest Payments (BoP, current US$) in Samoa?
Ensure brevity in your answer.  1.14e+08. 